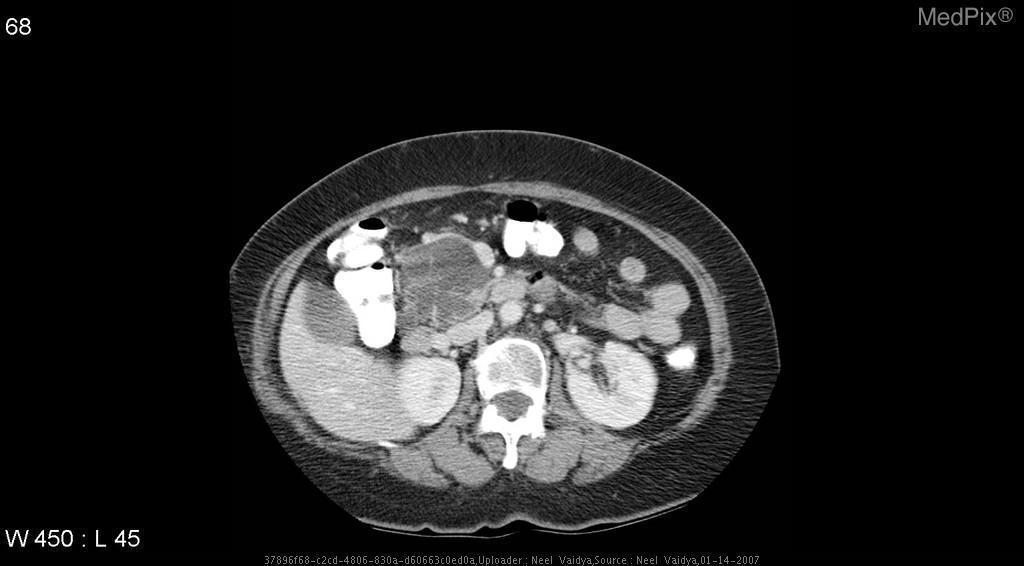What image modality is this?
Keep it brief. Ct. What imaging modality was used
Keep it brief. Ct. Are there multiple septations within the cyst?
Answer briefly. Yes. Is the cyst complex?
Write a very short answer. Yes. What organ is involved?
Short answer required. Pancreas. Which organ is affected?
Write a very short answer. Pancreas. Are calcifications present?
Be succinct. Yes. 